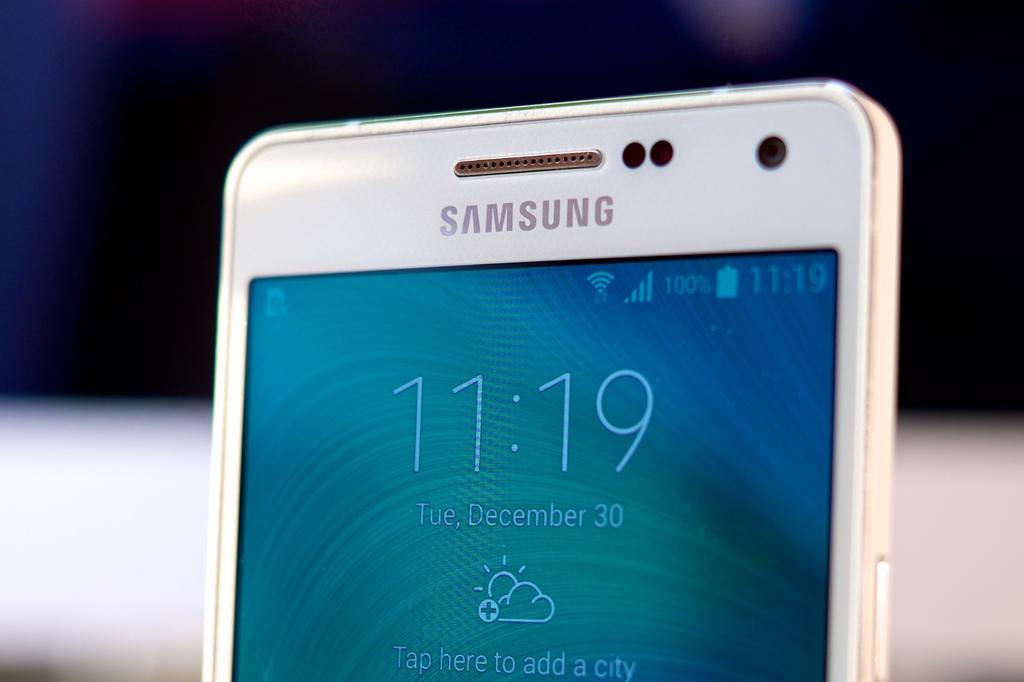Who makes this phone?
Provide a succinct answer. Samsung. Samsung 11:19 tue, december 30 tap here to add a city?
Give a very brief answer. Not a question. 